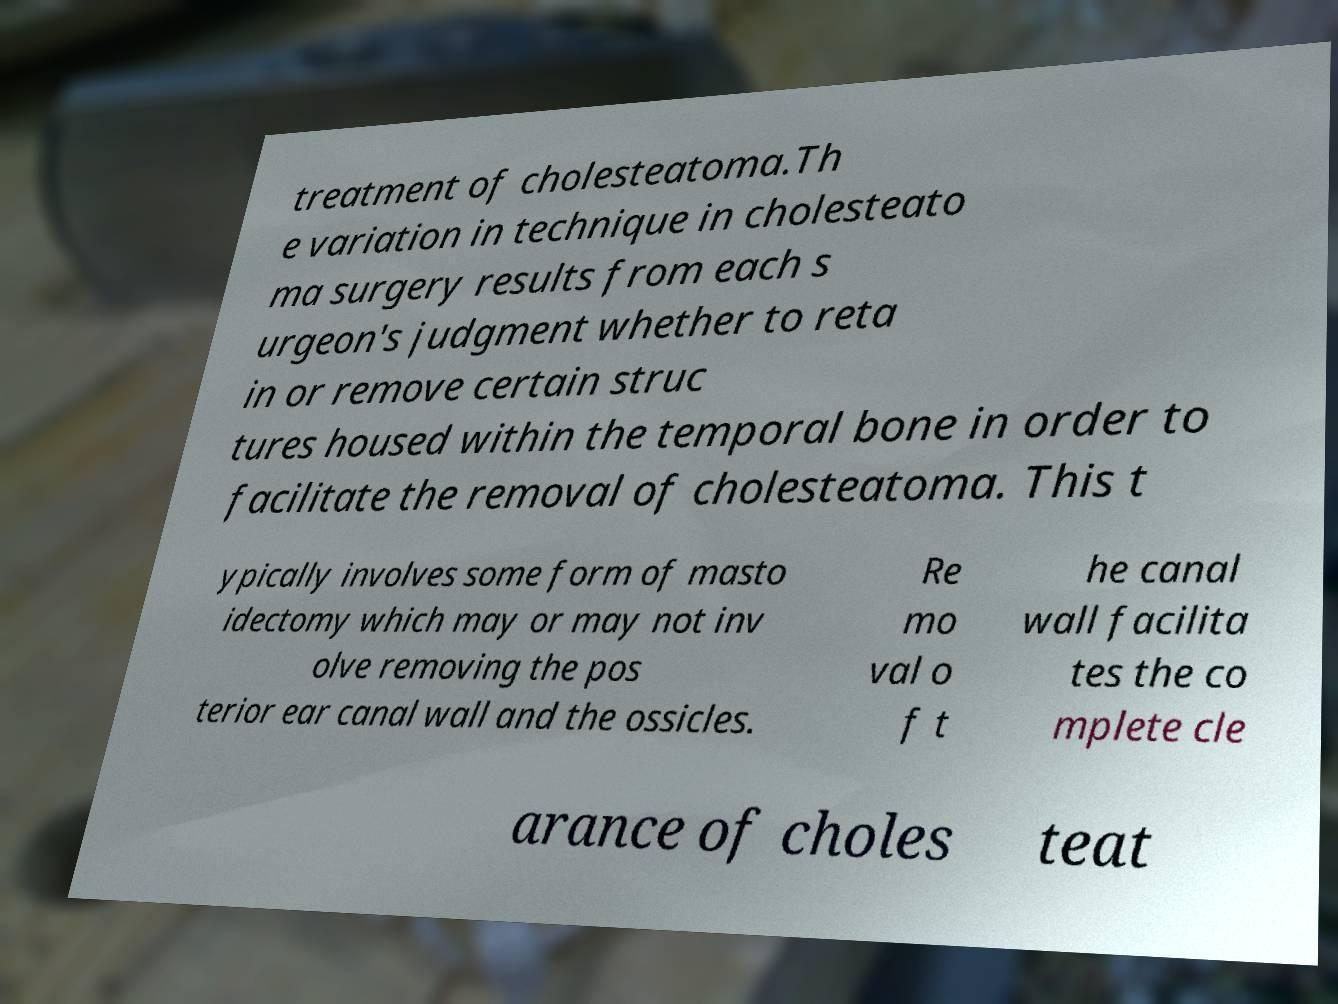Can you read and provide the text displayed in the image?This photo seems to have some interesting text. Can you extract and type it out for me? treatment of cholesteatoma.Th e variation in technique in cholesteato ma surgery results from each s urgeon's judgment whether to reta in or remove certain struc tures housed within the temporal bone in order to facilitate the removal of cholesteatoma. This t ypically involves some form of masto idectomy which may or may not inv olve removing the pos terior ear canal wall and the ossicles. Re mo val o f t he canal wall facilita tes the co mplete cle arance of choles teat 